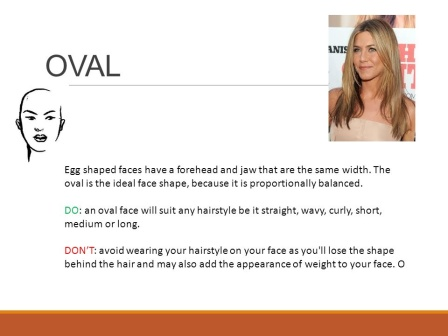Can you explain why the 'oval' face shape is considered ideal in hairstyling? The 'oval' face shape is often labeled as ideal because its proportions are balanced, allowing it to suit a wide range of hairstyles. This symmetry makes it easier to work with as almost any hairstyle tends to be flattering, offering a versatile canvas for hairstylists. What hairstyles are specifically recommended for this face shape, according to the image? According to the slide, an oval face shape can pull off nearly any hairstyle, whether it's straight, wavy, curly, short, medium, or long. The key is to choose styles that maintain the natural balance of the face without adding apparent weight to any area, aiming to preserve its oval symmetry. 